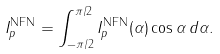Convert formula to latex. <formula><loc_0><loc_0><loc_500><loc_500>I _ { p } ^ { \text {NFN} } = \int _ { - \pi / 2 } ^ { \pi / 2 } I _ { p } ^ { \text {NFN} } ( \alpha ) \cos \alpha \, d \alpha .</formula> 